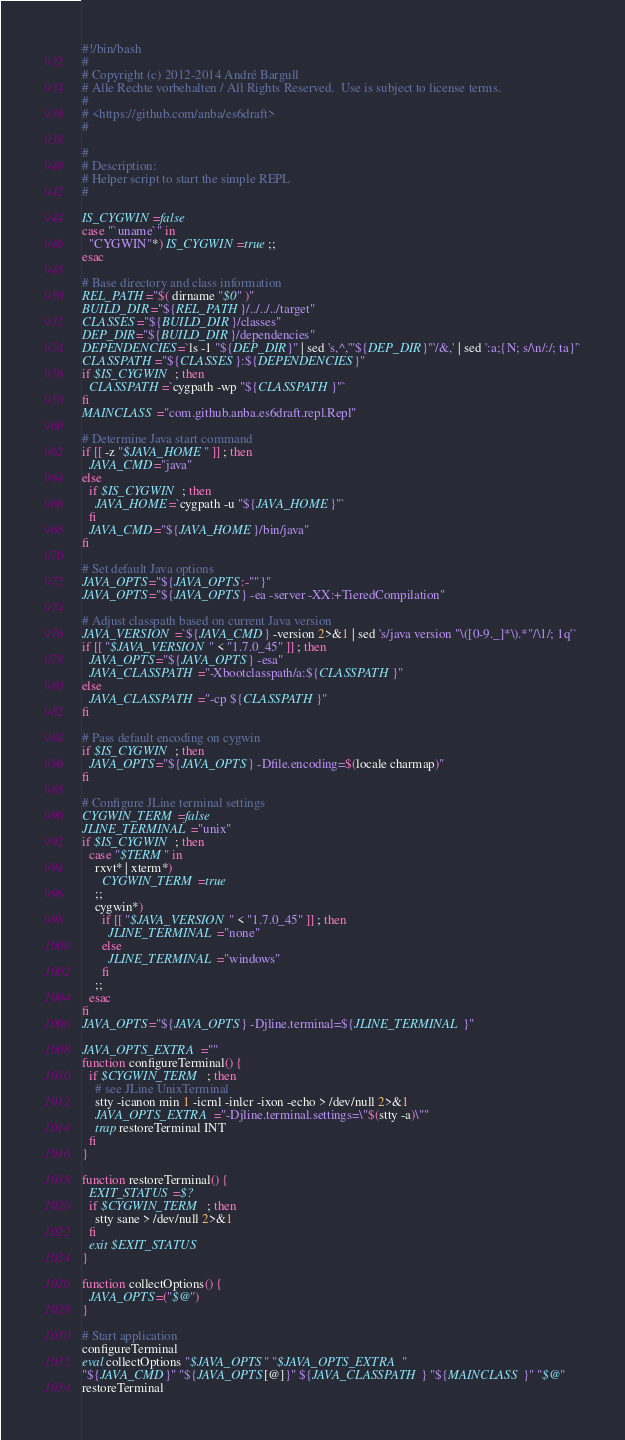<code> <loc_0><loc_0><loc_500><loc_500><_Bash_>#!/bin/bash
#
# Copyright (c) 2012-2014 André Bargull
# Alle Rechte vorbehalten / All Rights Reserved.  Use is subject to license terms.
#
# <https://github.com/anba/es6draft>
#

#
# Description:
# Helper script to start the simple REPL
#

IS_CYGWIN=false
case "`uname`" in
  "CYGWIN"*) IS_CYGWIN=true ;;
esac

# Base directory and class information
REL_PATH="$( dirname "$0" )"
BUILD_DIR="${REL_PATH}/../../../target"
CLASSES="${BUILD_DIR}/classes"
DEP_DIR="${BUILD_DIR}/dependencies"
DEPENDENCIES=`ls -1 "${DEP_DIR}" | sed 's,^,'"${DEP_DIR}"'/&,' | sed ':a;{N; s/\n/:/; ta}'`
CLASSPATH="${CLASSES}:${DEPENDENCIES}"
if $IS_CYGWIN ; then
  CLASSPATH=`cygpath -wp "${CLASSPATH}"`
fi
MAINCLASS="com.github.anba.es6draft.repl.Repl"

# Determine Java start command
if [[ -z "$JAVA_HOME" ]] ; then
  JAVA_CMD="java"
else
  if $IS_CYGWIN ; then
    JAVA_HOME=`cygpath -u "${JAVA_HOME}"`
  fi
  JAVA_CMD="${JAVA_HOME}/bin/java"
fi

# Set default Java options
JAVA_OPTS="${JAVA_OPTS:-""}"
JAVA_OPTS="${JAVA_OPTS} -ea -server -XX:+TieredCompilation"

# Adjust classpath based on current Java version
JAVA_VERSION=`${JAVA_CMD} -version 2>&1 | sed 's/java version "\([0-9._]*\).*"/\1/; 1q'`
if [[ "$JAVA_VERSION" < "1.7.0_45" ]] ; then
  JAVA_OPTS="${JAVA_OPTS} -esa"
  JAVA_CLASSPATH="-Xbootclasspath/a:${CLASSPATH}"
else
  JAVA_CLASSPATH="-cp ${CLASSPATH}"
fi

# Pass default encoding on cygwin
if $IS_CYGWIN ; then
  JAVA_OPTS="${JAVA_OPTS} -Dfile.encoding=$(locale charmap)"
fi

# Configure JLine terminal settings
CYGWIN_TERM=false
JLINE_TERMINAL="unix"
if $IS_CYGWIN ; then
  case "$TERM" in
    rxvt* | xterm*)
      CYGWIN_TERM=true
    ;;
    cygwin*)
      if [[ "$JAVA_VERSION" < "1.7.0_45" ]] ; then
        JLINE_TERMINAL="none"
      else
        JLINE_TERMINAL="windows"
      fi
    ;;
  esac
fi
JAVA_OPTS="${JAVA_OPTS} -Djline.terminal=${JLINE_TERMINAL}"

JAVA_OPTS_EXTRA=""
function configureTerminal() {
  if $CYGWIN_TERM ; then
    # see JLine UnixTerminal
    stty -icanon min 1 -icrnl -inlcr -ixon -echo > /dev/null 2>&1
    JAVA_OPTS_EXTRA="-Djline.terminal.settings=\"$(stty -a)\""
    trap restoreTerminal INT
  fi
}

function restoreTerminal() {
  EXIT_STATUS=$?
  if $CYGWIN_TERM ; then
    stty sane > /dev/null 2>&1
  fi
  exit $EXIT_STATUS
}

function collectOptions() {
  JAVA_OPTS=("$@")
}

# Start application
configureTerminal
eval collectOptions "$JAVA_OPTS" "$JAVA_OPTS_EXTRA"
"${JAVA_CMD}" "${JAVA_OPTS[@]}" ${JAVA_CLASSPATH} "${MAINCLASS}" "$@"
restoreTerminal
</code> 